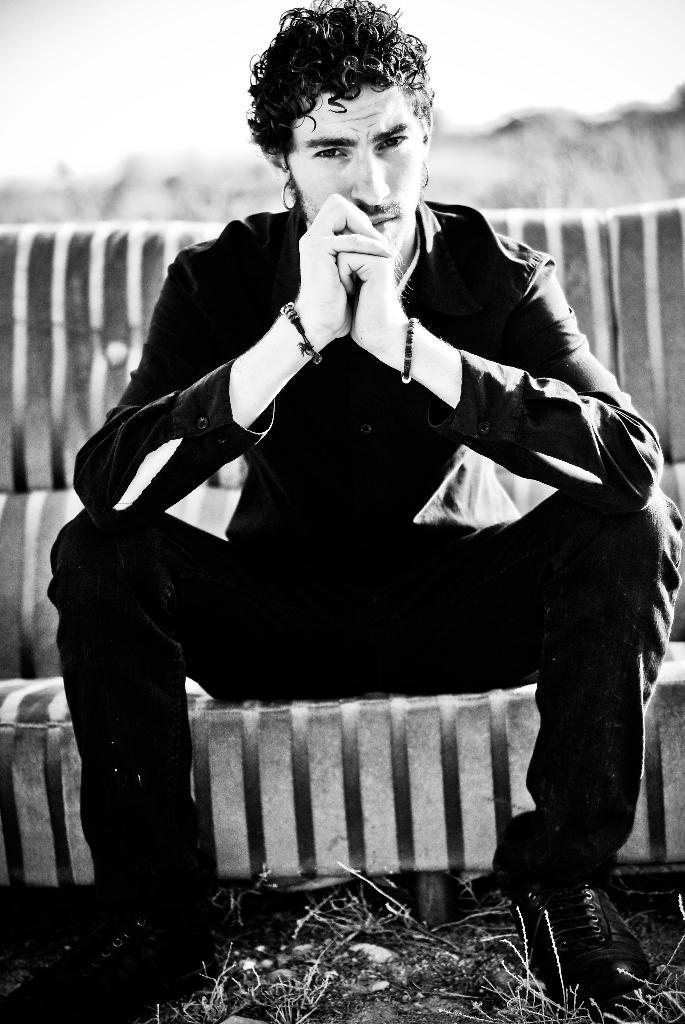What is the color scheme of the image? The image is black and white. Can you describe the main subject in the image? There is a man in the image. What is the man doing in the image? The man is sitting on a sofa. What type of carriage can be seen in the image? There is no carriage present in the image. What is the texture of the bit in the image? There is no bit present in the image. 